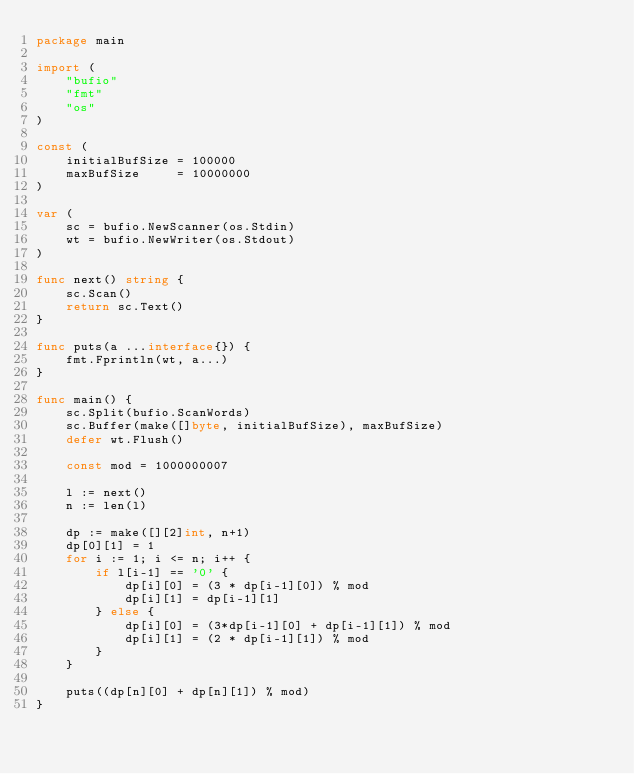<code> <loc_0><loc_0><loc_500><loc_500><_Go_>package main

import (
	"bufio"
	"fmt"
	"os"
)

const (
	initialBufSize = 100000
	maxBufSize     = 10000000
)

var (
	sc = bufio.NewScanner(os.Stdin)
	wt = bufio.NewWriter(os.Stdout)
)

func next() string {
	sc.Scan()
	return sc.Text()
}

func puts(a ...interface{}) {
	fmt.Fprintln(wt, a...)
}

func main() {
	sc.Split(bufio.ScanWords)
	sc.Buffer(make([]byte, initialBufSize), maxBufSize)
	defer wt.Flush()

	const mod = 1000000007

	l := next()
	n := len(l)

	dp := make([][2]int, n+1)
	dp[0][1] = 1
	for i := 1; i <= n; i++ {
		if l[i-1] == '0' {
			dp[i][0] = (3 * dp[i-1][0]) % mod
			dp[i][1] = dp[i-1][1]
		} else {
			dp[i][0] = (3*dp[i-1][0] + dp[i-1][1]) % mod
			dp[i][1] = (2 * dp[i-1][1]) % mod
		}
	}

	puts((dp[n][0] + dp[n][1]) % mod)
}
</code> 